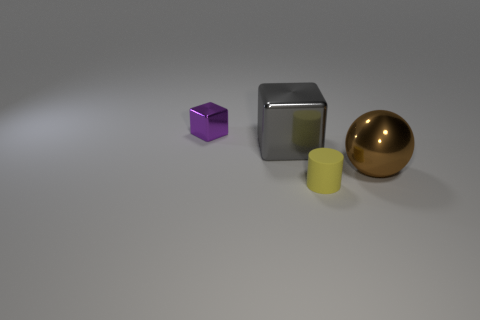Add 2 big red things. How many objects exist? 6 Subtract all large red balls. Subtract all large gray blocks. How many objects are left? 3 Add 2 yellow rubber cylinders. How many yellow rubber cylinders are left? 3 Add 4 small gray matte balls. How many small gray matte balls exist? 4 Subtract 0 purple cylinders. How many objects are left? 4 Subtract all cylinders. How many objects are left? 3 